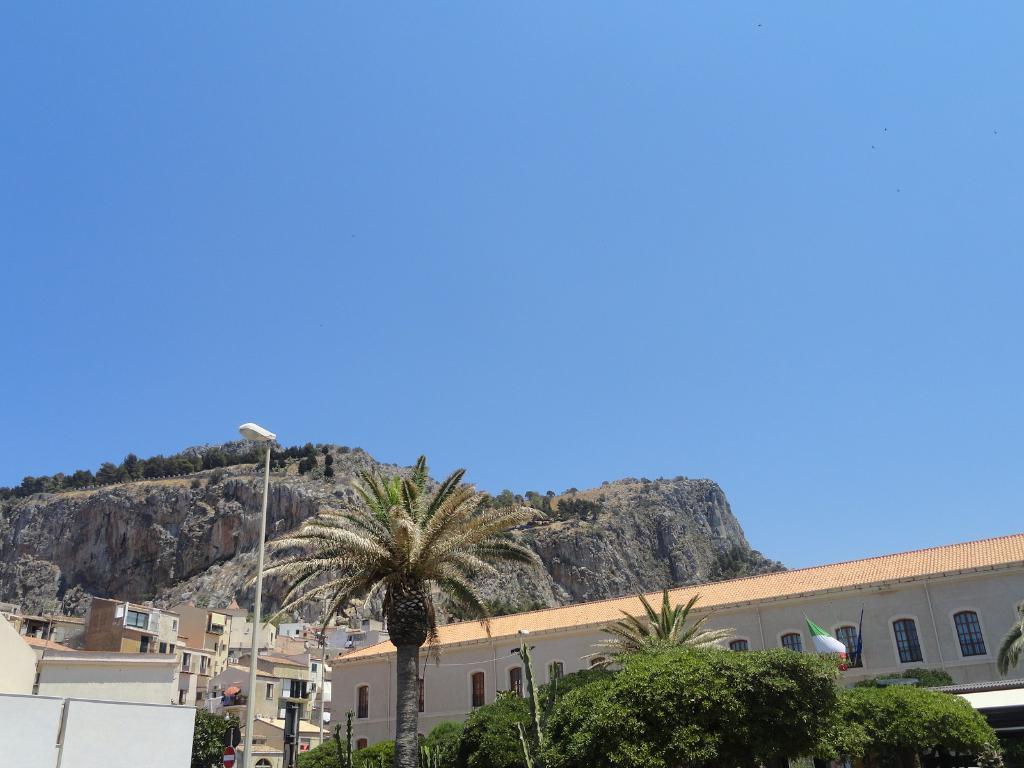Please provide a concise description of this image. In this image, at the bottom there are trees, poles, street lights, flag, buildings, cc camera. At the top there are hills, sky. 